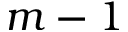<formula> <loc_0><loc_0><loc_500><loc_500>m - 1</formula> 